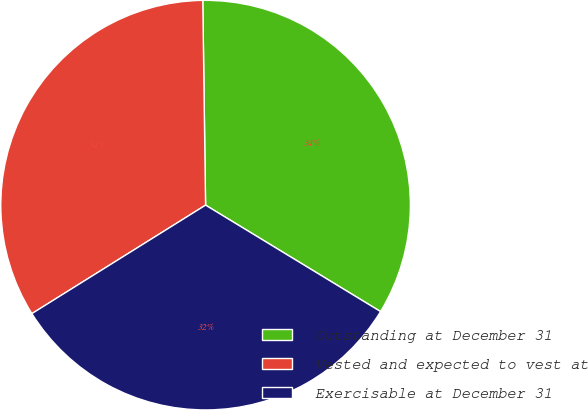Convert chart. <chart><loc_0><loc_0><loc_500><loc_500><pie_chart><fcel>Outstanding at December 31<fcel>Vested and expected to vest at<fcel>Exercisable at December 31<nl><fcel>33.92%<fcel>33.67%<fcel>32.42%<nl></chart> 